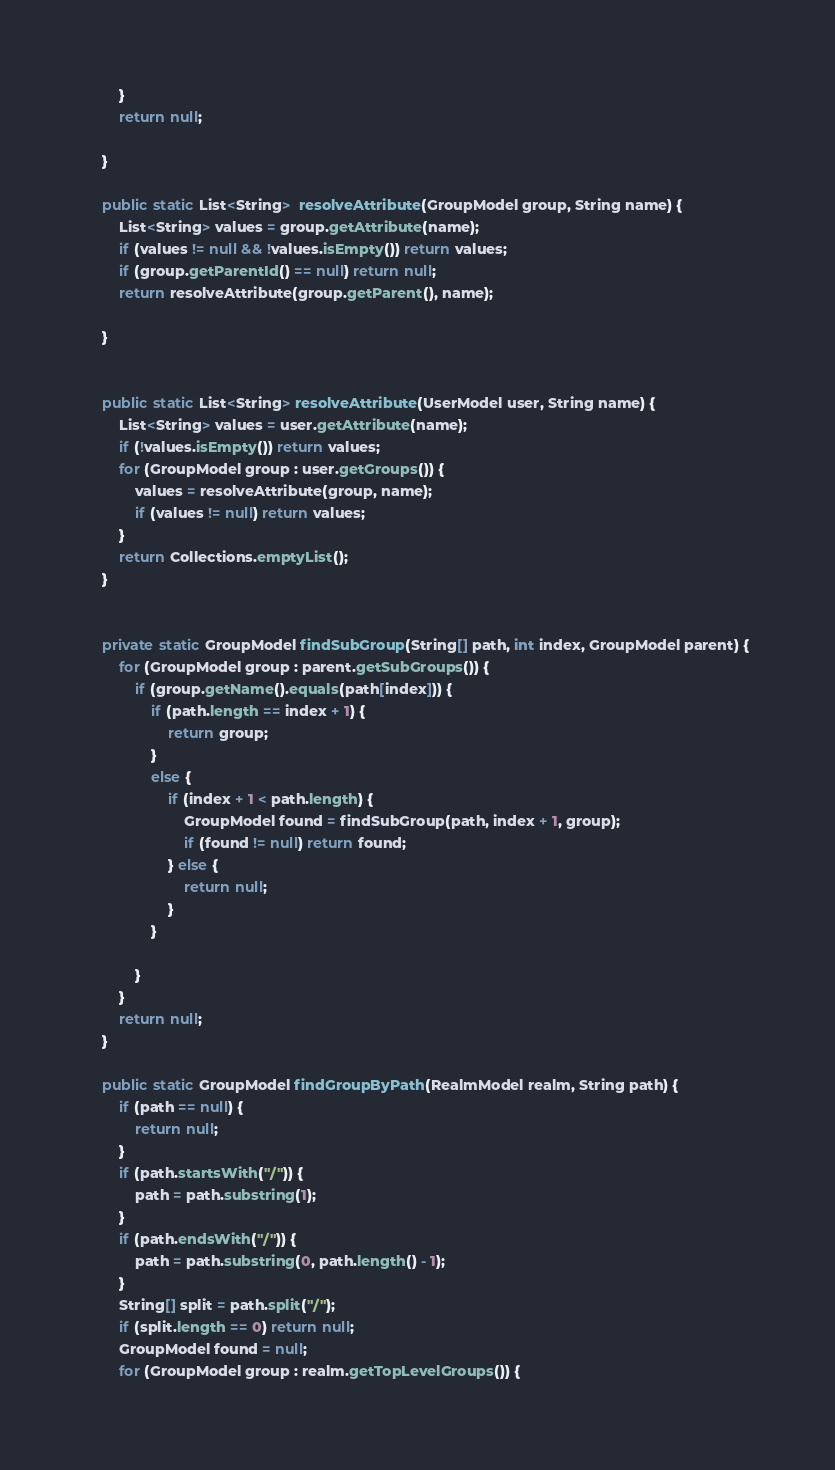<code> <loc_0><loc_0><loc_500><loc_500><_Java_>        }
        return null;

    }

    public static List<String>  resolveAttribute(GroupModel group, String name) {
        List<String> values = group.getAttribute(name);
        if (values != null && !values.isEmpty()) return values;
        if (group.getParentId() == null) return null;
        return resolveAttribute(group.getParent(), name);

    }


    public static List<String> resolveAttribute(UserModel user, String name) {
        List<String> values = user.getAttribute(name);
        if (!values.isEmpty()) return values;
        for (GroupModel group : user.getGroups()) {
            values = resolveAttribute(group, name);
            if (values != null) return values;
        }
        return Collections.emptyList();
    }


    private static GroupModel findSubGroup(String[] path, int index, GroupModel parent) {
        for (GroupModel group : parent.getSubGroups()) {
            if (group.getName().equals(path[index])) {
                if (path.length == index + 1) {
                    return group;
                }
                else {
                    if (index + 1 < path.length) {
                        GroupModel found = findSubGroup(path, index + 1, group);
                        if (found != null) return found;
                    } else {
                        return null;
                    }
                }

            }
        }
        return null;
    }

    public static GroupModel findGroupByPath(RealmModel realm, String path) {
        if (path == null) {
            return null;
        }
        if (path.startsWith("/")) {
            path = path.substring(1);
        }
        if (path.endsWith("/")) {
            path = path.substring(0, path.length() - 1);
        }
        String[] split = path.split("/");
        if (split.length == 0) return null;
        GroupModel found = null;
        for (GroupModel group : realm.getTopLevelGroups()) {</code> 